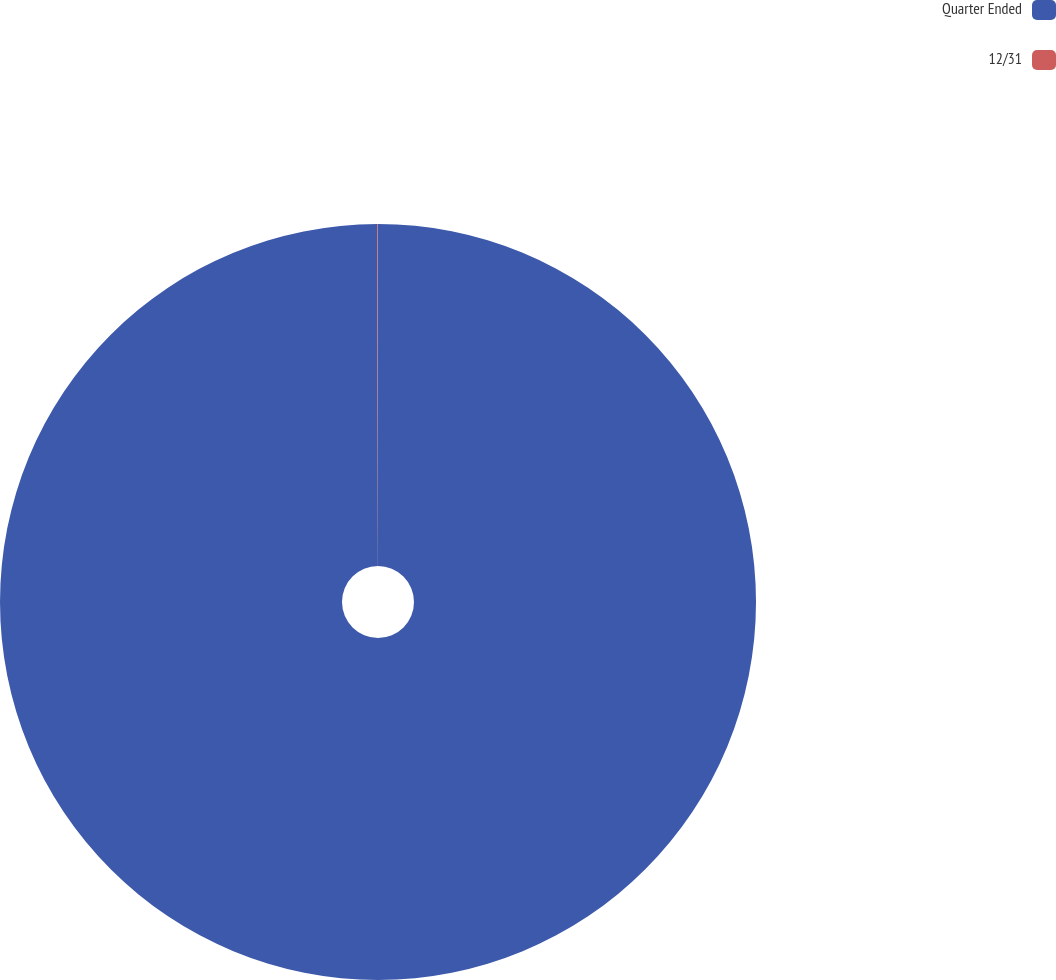Convert chart to OTSL. <chart><loc_0><loc_0><loc_500><loc_500><pie_chart><fcel>Quarter Ended<fcel>12/31<nl><fcel>99.97%<fcel>0.03%<nl></chart> 